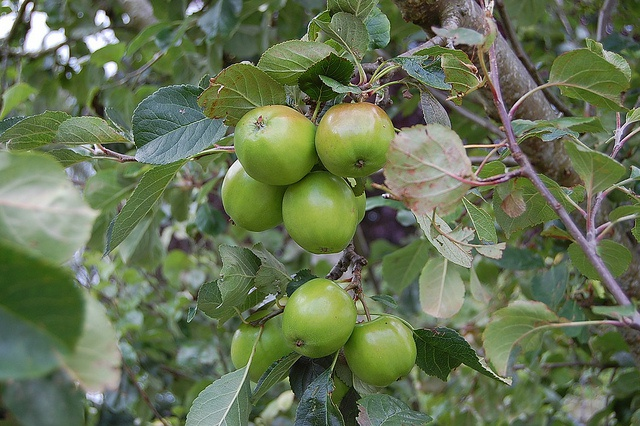Describe the objects in this image and their specific colors. I can see apple in olive, khaki, darkgreen, and beige tones, apple in olive and darkgreen tones, apple in olive and darkgreen tones, apple in olive, darkgreen, and beige tones, and apple in olive, darkgreen, and darkgray tones in this image. 